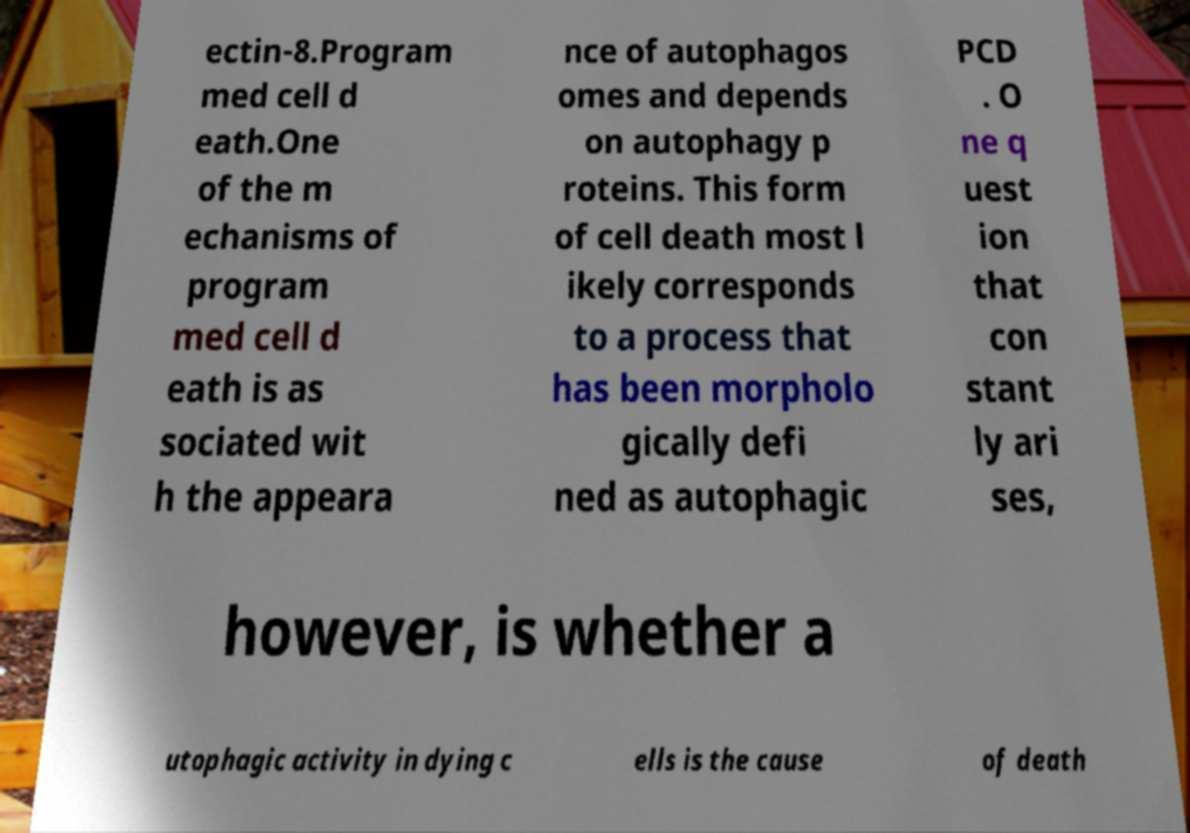Please read and relay the text visible in this image. What does it say? ectin-8.Program med cell d eath.One of the m echanisms of program med cell d eath is as sociated wit h the appeara nce of autophagos omes and depends on autophagy p roteins. This form of cell death most l ikely corresponds to a process that has been morpholo gically defi ned as autophagic PCD . O ne q uest ion that con stant ly ari ses, however, is whether a utophagic activity in dying c ells is the cause of death 